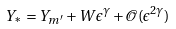<formula> <loc_0><loc_0><loc_500><loc_500>Y _ { * } = Y _ { m ^ { \prime } } + W \epsilon ^ { \gamma } + \mathcal { O } ( \epsilon ^ { 2 \gamma } )</formula> 